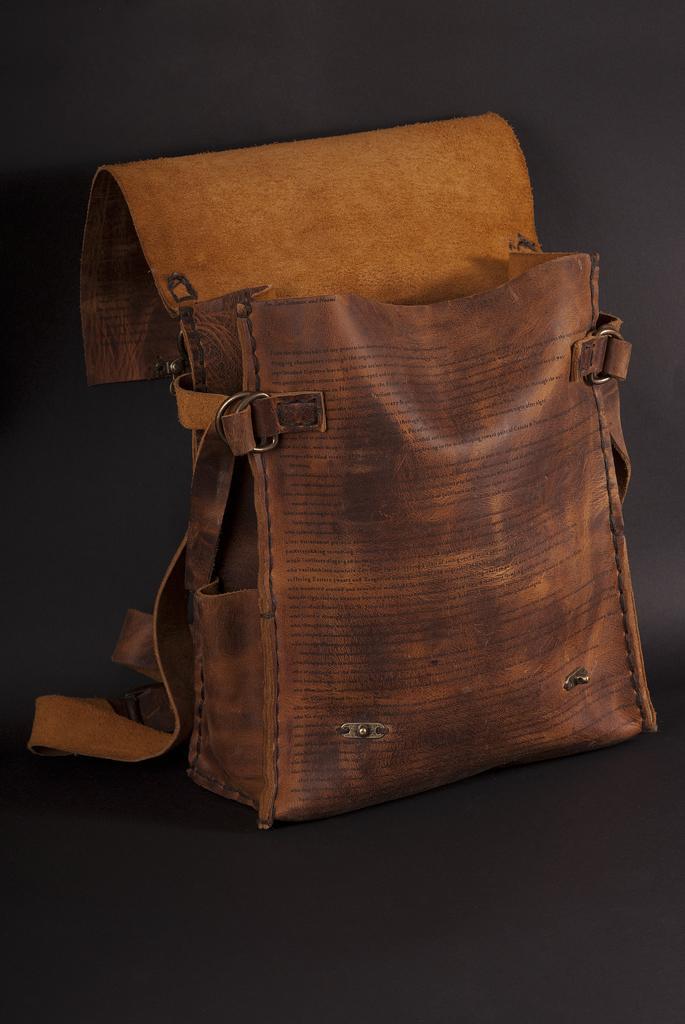How would you summarize this image in a sentence or two? In this picture there is a bag. 